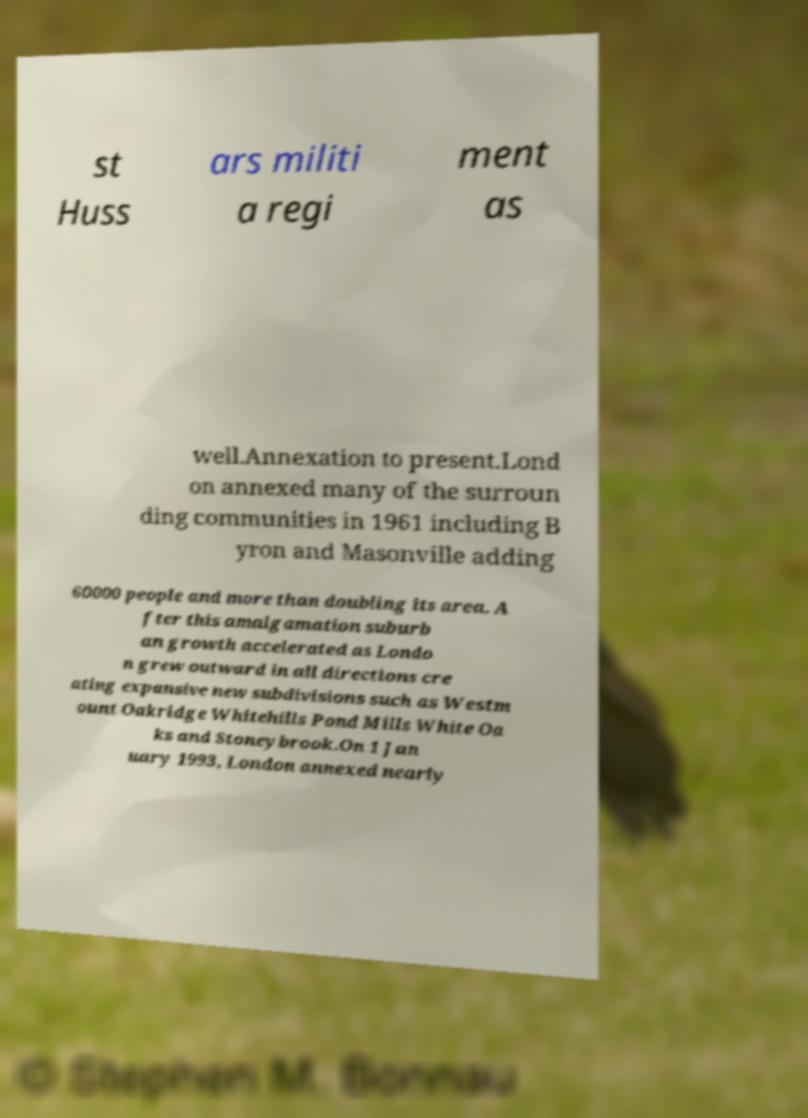What messages or text are displayed in this image? I need them in a readable, typed format. st Huss ars militi a regi ment as well.Annexation to present.Lond on annexed many of the surroun ding communities in 1961 including B yron and Masonville adding 60000 people and more than doubling its area. A fter this amalgamation suburb an growth accelerated as Londo n grew outward in all directions cre ating expansive new subdivisions such as Westm ount Oakridge Whitehills Pond Mills White Oa ks and Stoneybrook.On 1 Jan uary 1993, London annexed nearly 